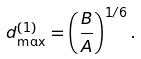<formula> <loc_0><loc_0><loc_500><loc_500>d _ { \max } ^ { ( 1 ) } = \left ( \frac { B } { A } \right ) ^ { 1 / 6 } .</formula> 